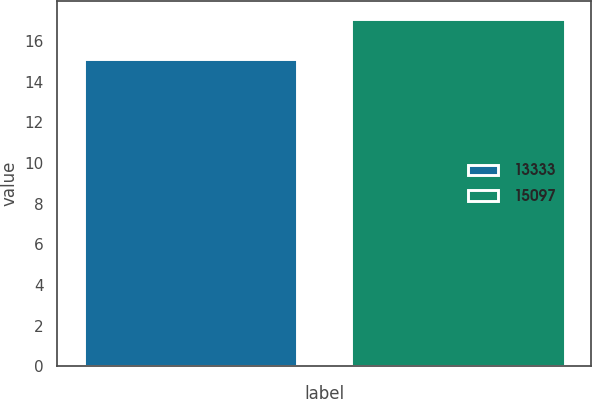Convert chart. <chart><loc_0><loc_0><loc_500><loc_500><bar_chart><fcel>13333<fcel>15097<nl><fcel>15.1<fcel>17.1<nl></chart> 